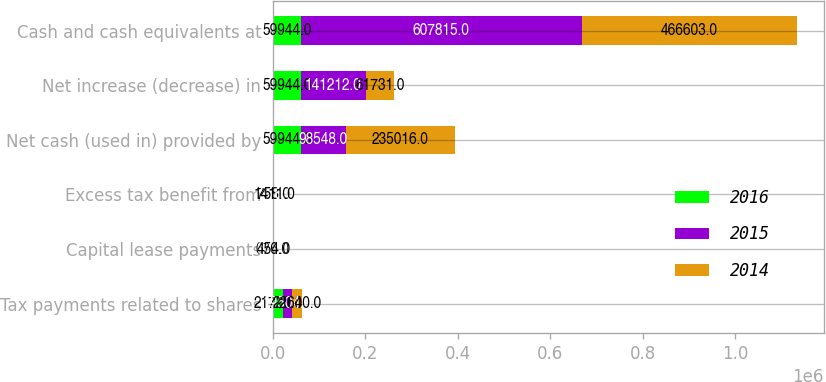<chart> <loc_0><loc_0><loc_500><loc_500><stacked_bar_chart><ecel><fcel>Tax payments related to shares<fcel>Capital lease payments<fcel>Excess tax benefit from<fcel>Net cash (used in) provided by<fcel>Net increase (decrease) in<fcel>Cash and cash equivalents at<nl><fcel>2016<fcel>21720<fcel>676<fcel>758<fcel>59944<fcel>59944<fcel>59944<nl><fcel>2015<fcel>19504<fcel>604<fcel>1216<fcel>98548<fcel>141212<fcel>607815<nl><fcel>2014<fcel>22640<fcel>454<fcel>1411<fcel>235016<fcel>61731<fcel>466603<nl></chart> 